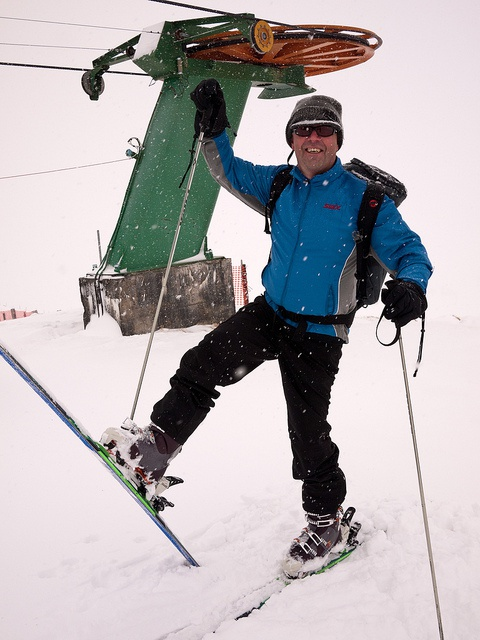Describe the objects in this image and their specific colors. I can see people in lightgray, black, blue, and gray tones, snowboard in lightgray, teal, darkgreen, and black tones, backpack in lightgray, black, gray, navy, and blue tones, and skis in lightgray, gray, and darkgray tones in this image. 